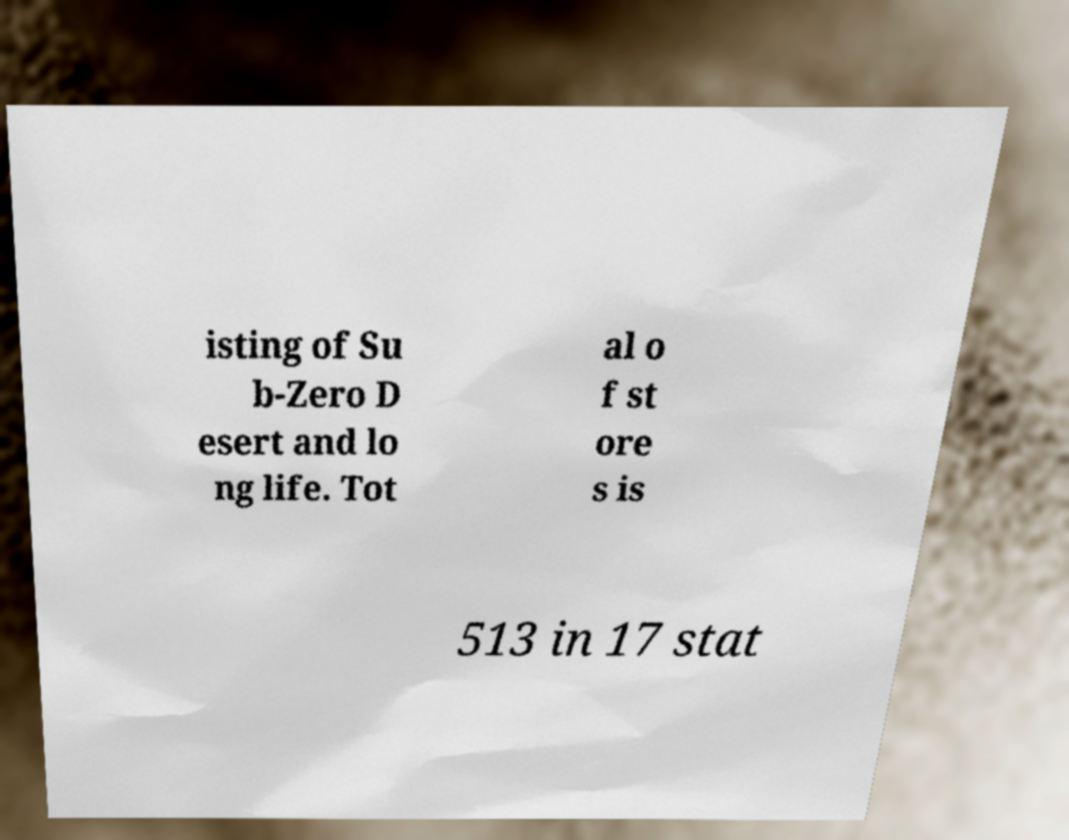I need the written content from this picture converted into text. Can you do that? isting of Su b-Zero D esert and lo ng life. Tot al o f st ore s is 513 in 17 stat 